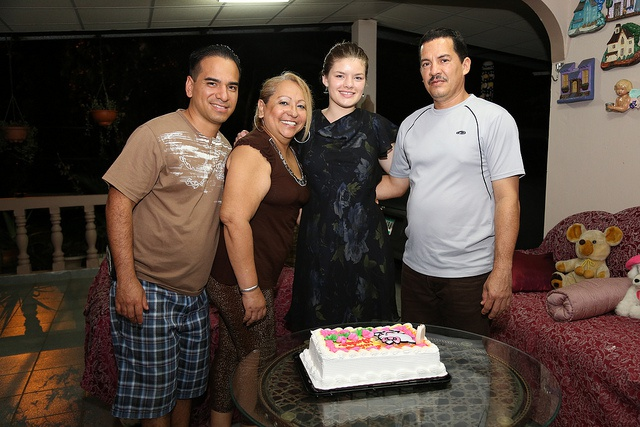Describe the objects in this image and their specific colors. I can see people in black, gray, and tan tones, people in black, lightgray, darkgray, and gray tones, dining table in black, ivory, gray, and maroon tones, people in black, tan, and gray tones, and people in black, salmon, tan, and maroon tones in this image. 